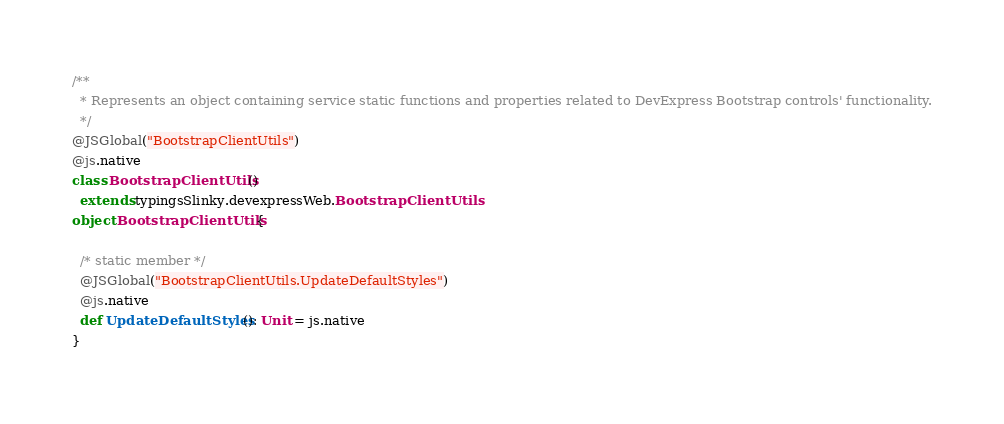Convert code to text. <code><loc_0><loc_0><loc_500><loc_500><_Scala_>/**
  * Represents an object containing service static functions and properties related to DevExpress Bootstrap controls' functionality.
  */
@JSGlobal("BootstrapClientUtils")
@js.native
class BootstrapClientUtils ()
  extends typingsSlinky.devexpressWeb.BootstrapClientUtils
object BootstrapClientUtils {
  
  /* static member */
  @JSGlobal("BootstrapClientUtils.UpdateDefaultStyles")
  @js.native
  def UpdateDefaultStyles(): Unit = js.native
}
</code> 